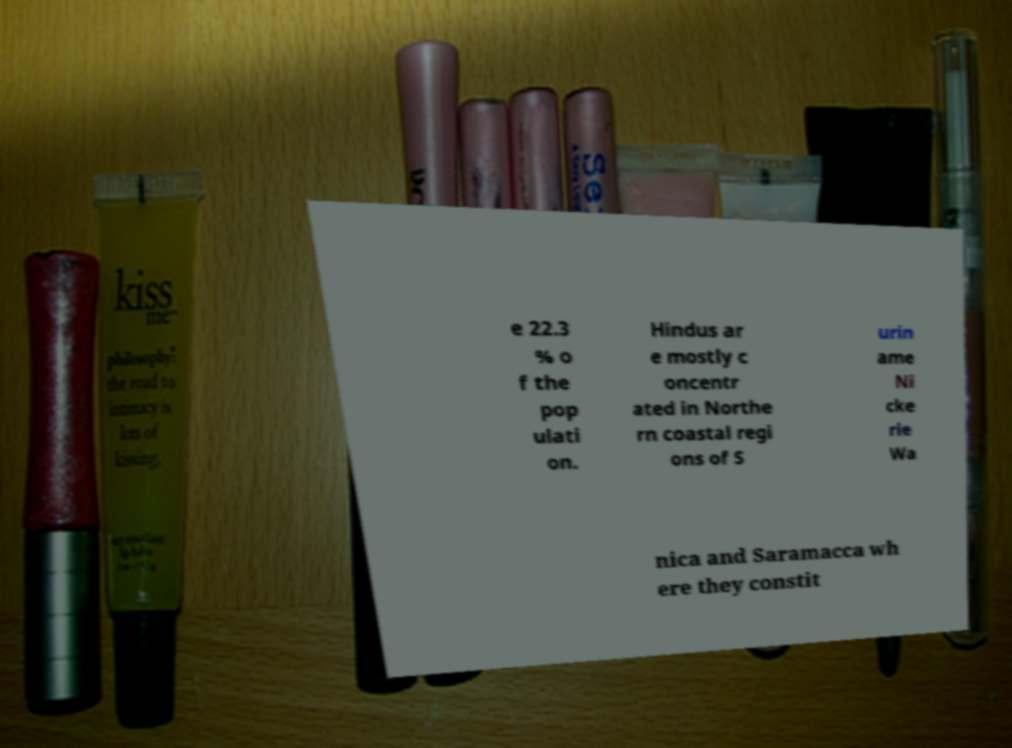Please read and relay the text visible in this image. What does it say? e 22.3 % o f the pop ulati on. Hindus ar e mostly c oncentr ated in Northe rn coastal regi ons of S urin ame Ni cke rie Wa nica and Saramacca wh ere they constit 